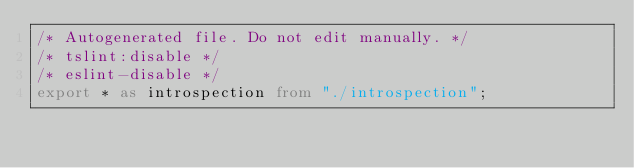Convert code to text. <code><loc_0><loc_0><loc_500><loc_500><_TypeScript_>/* Autogenerated file. Do not edit manually. */
/* tslint:disable */
/* eslint-disable */
export * as introspection from "./introspection";
</code> 